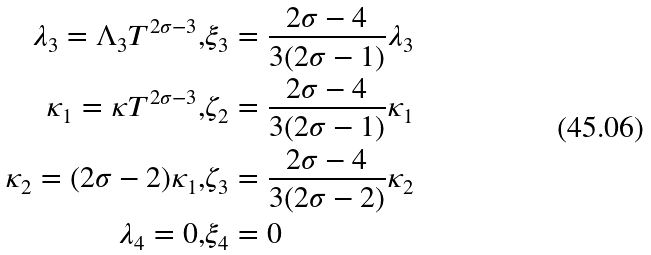<formula> <loc_0><loc_0><loc_500><loc_500>\lambda _ { 3 } = \Lambda _ { 3 } T ^ { 2 \sigma - 3 } , & \xi _ { 3 } = \frac { 2 \sigma - 4 } { 3 ( 2 \sigma - 1 ) } \lambda _ { 3 } \\ \kappa _ { 1 } = \kappa T ^ { 2 \sigma - 3 } , & \zeta _ { 2 } = \frac { 2 \sigma - 4 } { 3 ( 2 \sigma - 1 ) } \kappa _ { 1 } \\ \kappa _ { 2 } = ( 2 \sigma - 2 ) \kappa _ { 1 } , & \zeta _ { 3 } = \frac { 2 \sigma - 4 } { 3 ( 2 \sigma - 2 ) } \kappa _ { 2 } \\ \lambda _ { 4 } = 0 , & \xi _ { 4 } = 0</formula> 